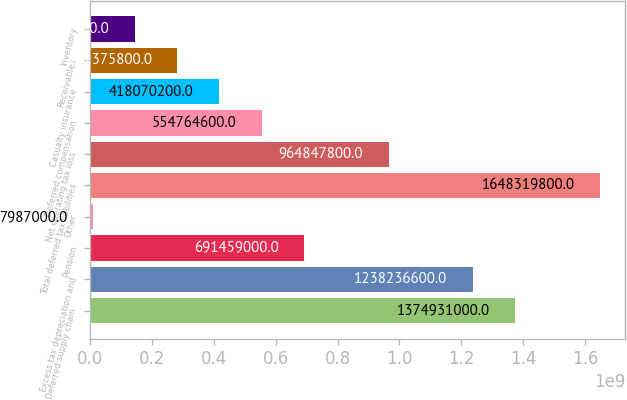<chart> <loc_0><loc_0><loc_500><loc_500><bar_chart><fcel>Deferred supply chain<fcel>Excess tax depreciation and<fcel>Pension<fcel>Other<fcel>Total deferred tax liabilities<fcel>Net operating tax loss<fcel>Deferred compensation<fcel>Casualty insurance<fcel>Receivables<fcel>Inventory<nl><fcel>1.37493e+09<fcel>1.23824e+09<fcel>6.91459e+08<fcel>7.987e+06<fcel>1.64832e+09<fcel>9.64848e+08<fcel>5.54765e+08<fcel>4.1807e+08<fcel>2.81376e+08<fcel>1.44681e+08<nl></chart> 